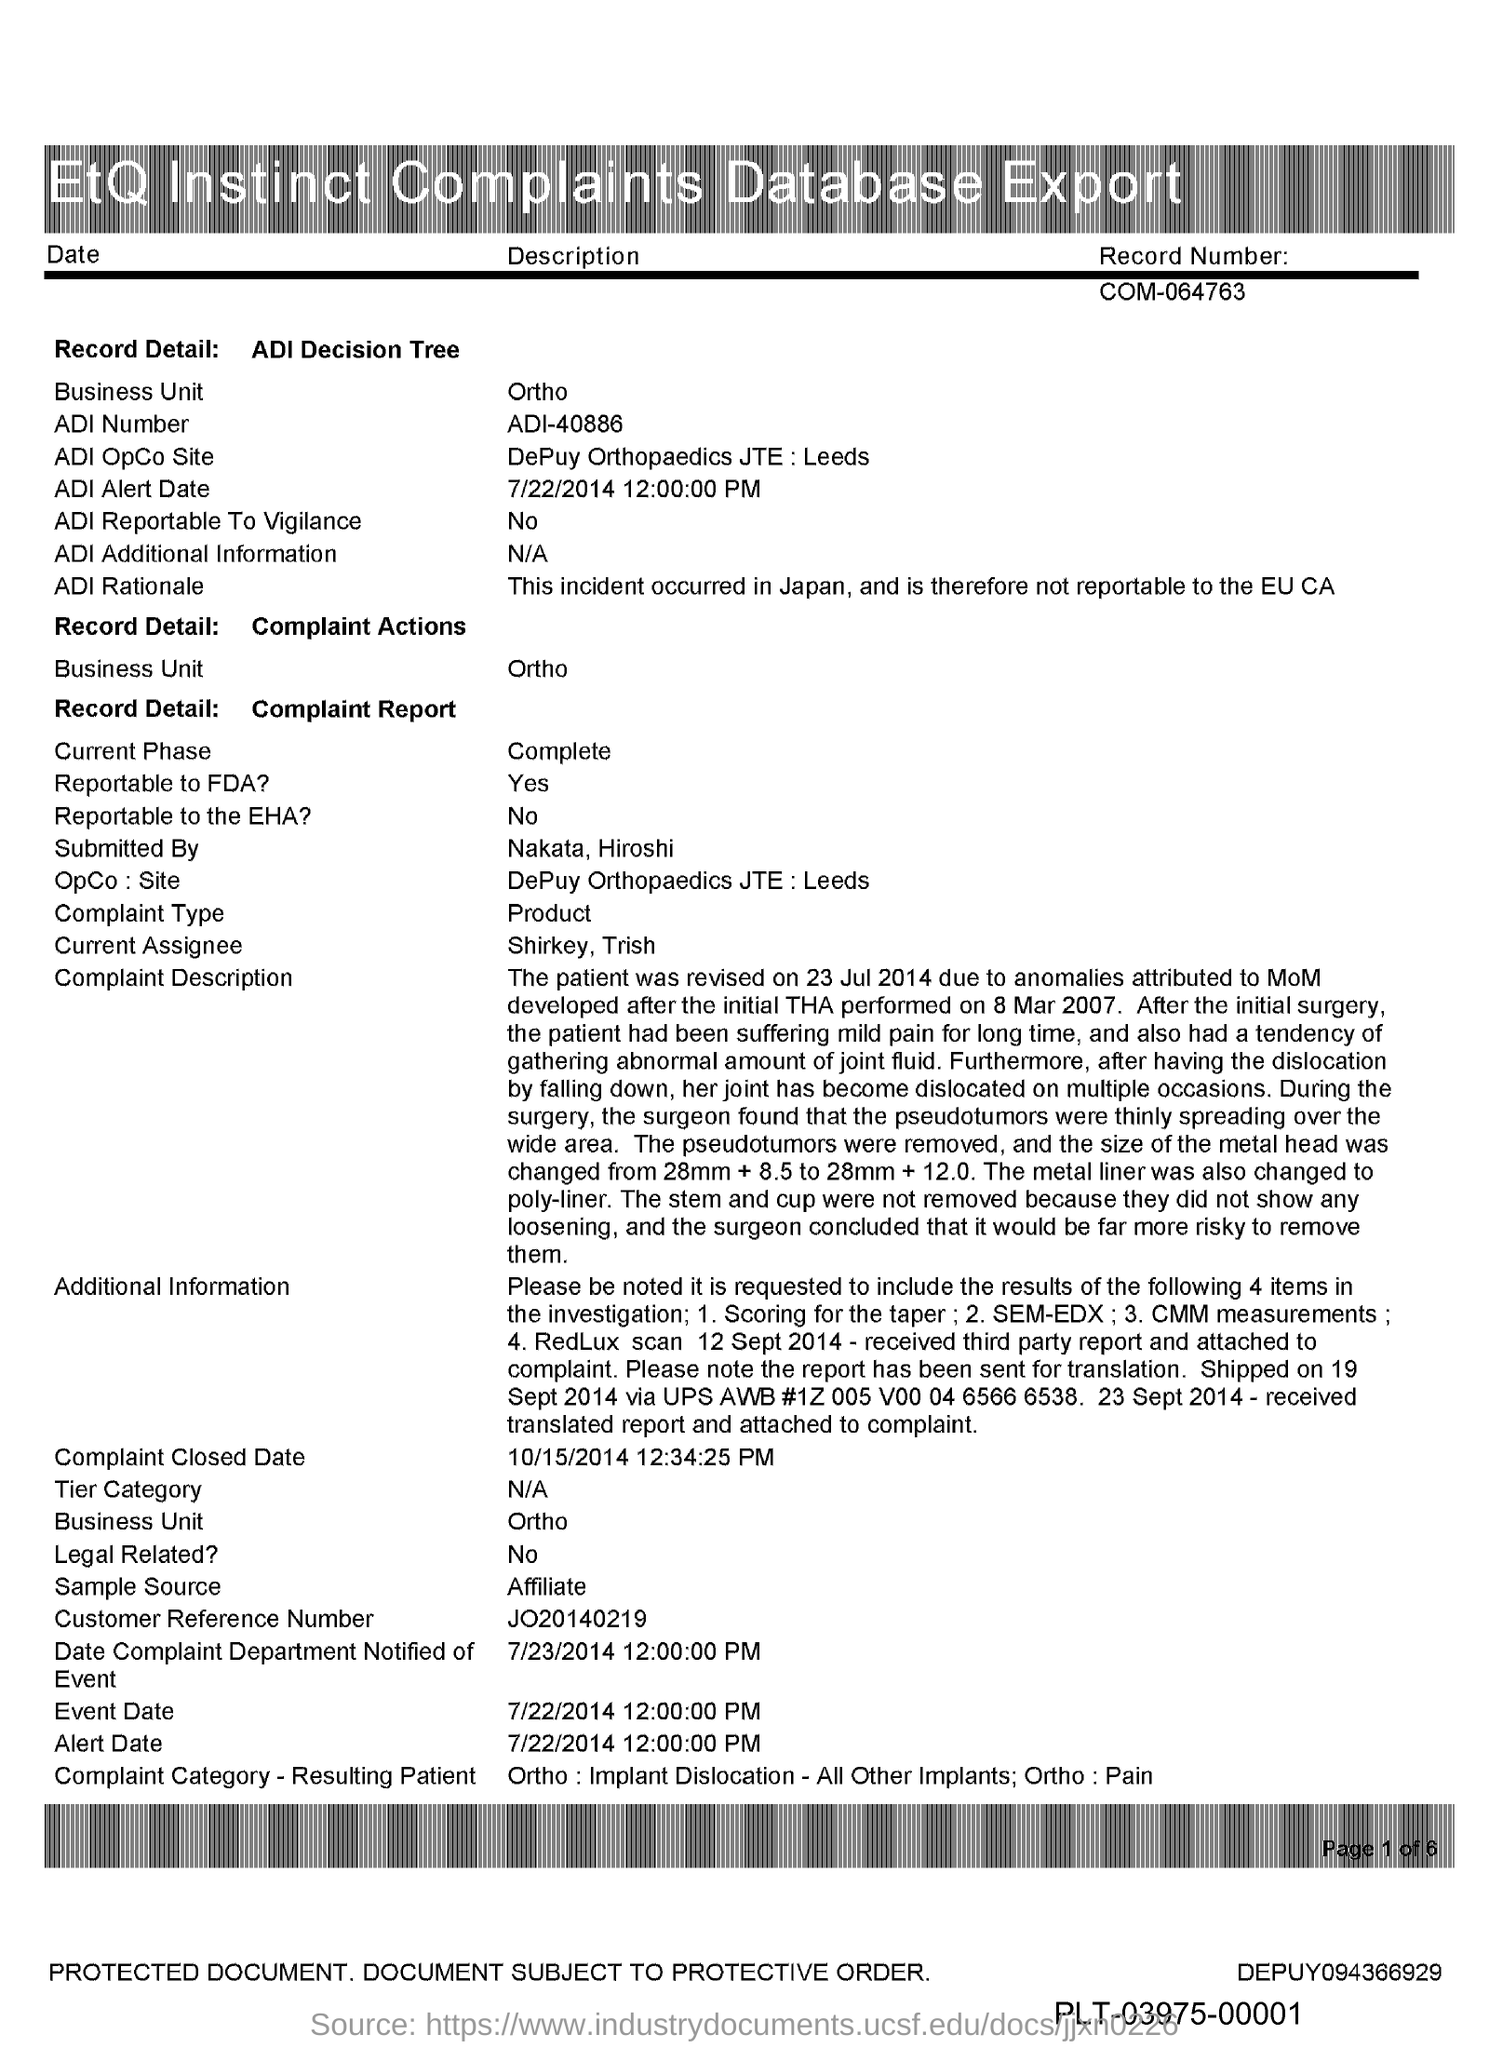Specify some key components in this picture. The title of the document is "Etiquette Instinct Complaints Database Export. The ADI number is ADI-40886. The record number is COM-064763.. 